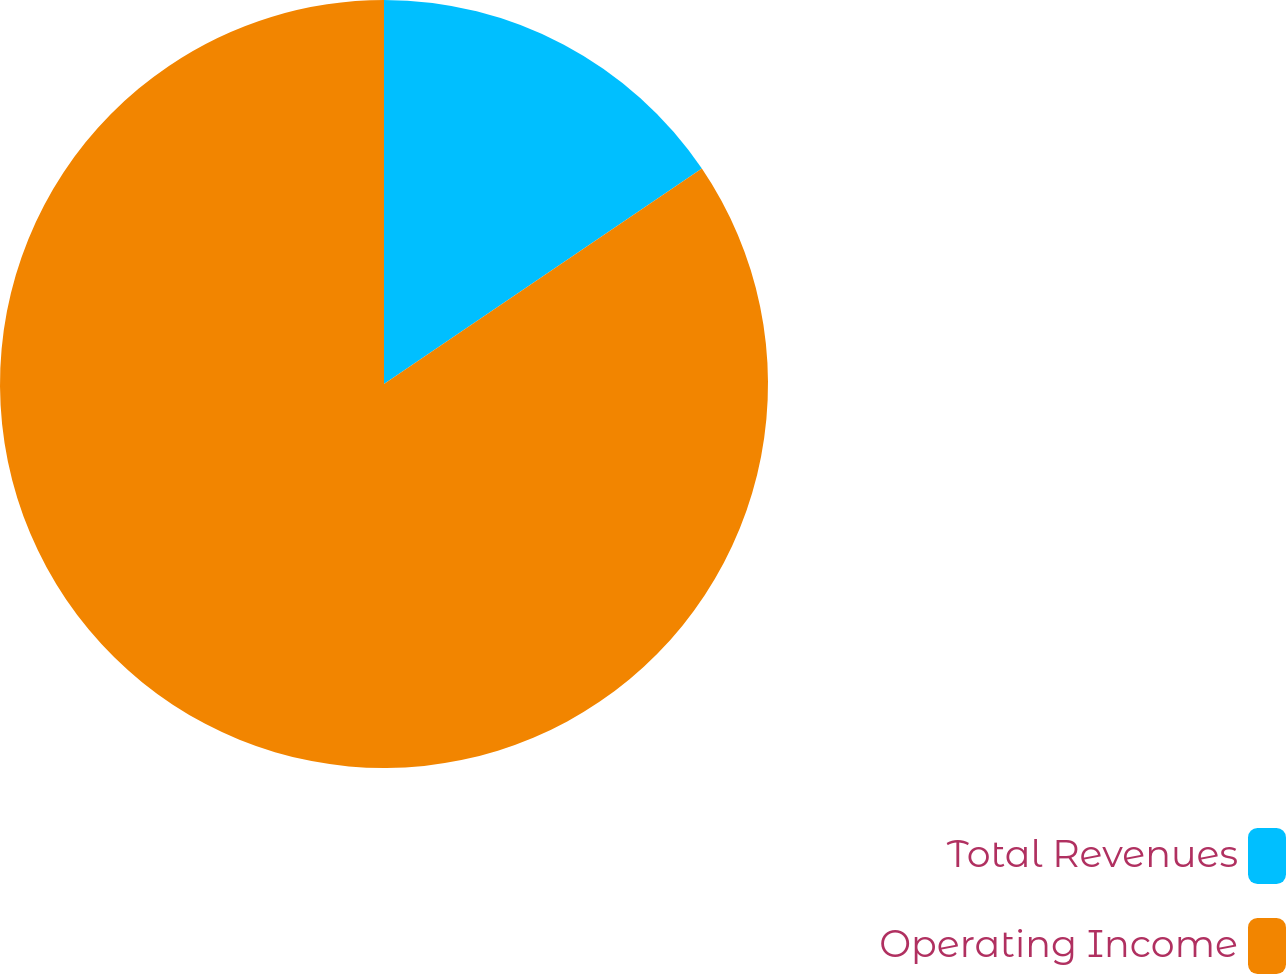<chart> <loc_0><loc_0><loc_500><loc_500><pie_chart><fcel>Total Revenues<fcel>Operating Income<nl><fcel>15.52%<fcel>84.48%<nl></chart> 